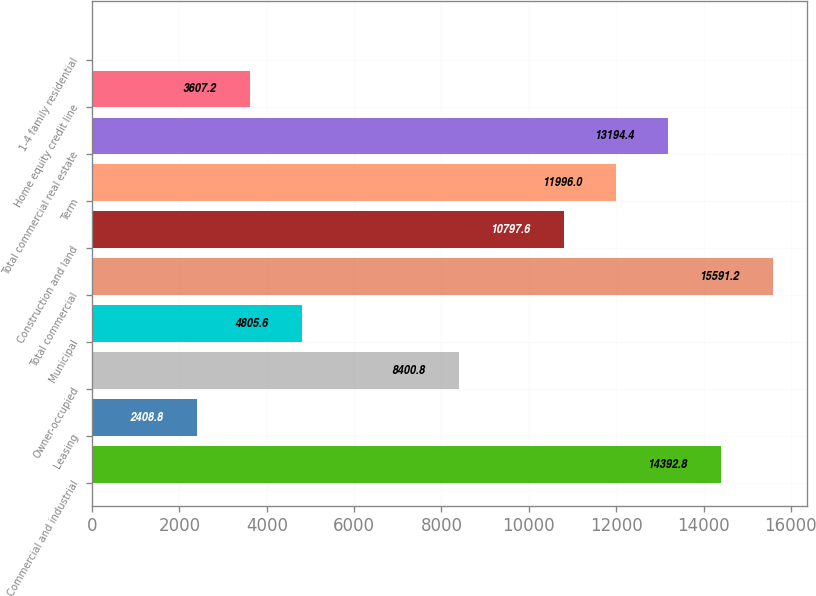<chart> <loc_0><loc_0><loc_500><loc_500><bar_chart><fcel>Commercial and industrial<fcel>Leasing<fcel>Owner-occupied<fcel>Municipal<fcel>Total commercial<fcel>Construction and land<fcel>Term<fcel>Total commercial real estate<fcel>Home equity credit line<fcel>1-4 family residential<nl><fcel>14392.8<fcel>2408.8<fcel>8400.8<fcel>4805.6<fcel>15591.2<fcel>10797.6<fcel>11996<fcel>13194.4<fcel>3607.2<fcel>12<nl></chart> 